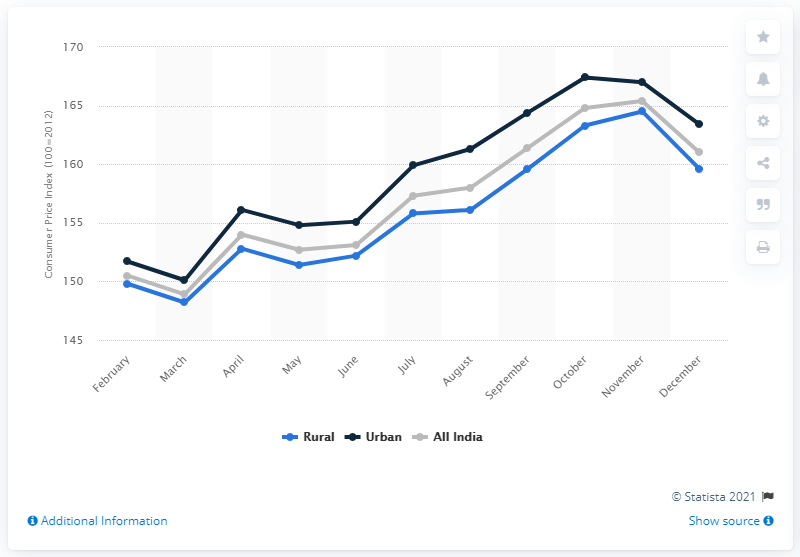Draw attention to some important aspects in this diagram. The Consumer Price Index for food and beverages across urban areas in India in July 2020 was 159.9. 